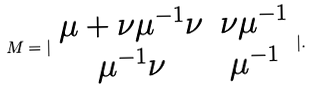<formula> <loc_0><loc_0><loc_500><loc_500>M = | \begin{array} { c c } \mu + \nu \mu ^ { - 1 } \nu & \nu \mu ^ { - 1 } \\ \mu ^ { - 1 } \nu & \mu ^ { - 1 } \end{array} | .</formula> 